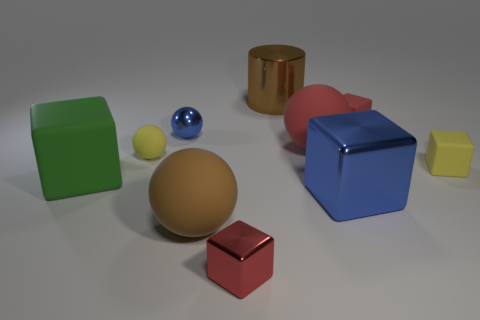Subtract 1 blocks. How many blocks are left? 4 Subtract all yellow cubes. How many cubes are left? 4 Subtract all big blue metallic cubes. How many cubes are left? 4 Subtract all gray blocks. Subtract all gray spheres. How many blocks are left? 5 Subtract all balls. How many objects are left? 6 Add 7 yellow rubber balls. How many yellow rubber balls exist? 8 Subtract 0 cyan balls. How many objects are left? 10 Subtract all big gray metallic cylinders. Subtract all large matte things. How many objects are left? 7 Add 2 yellow blocks. How many yellow blocks are left? 3 